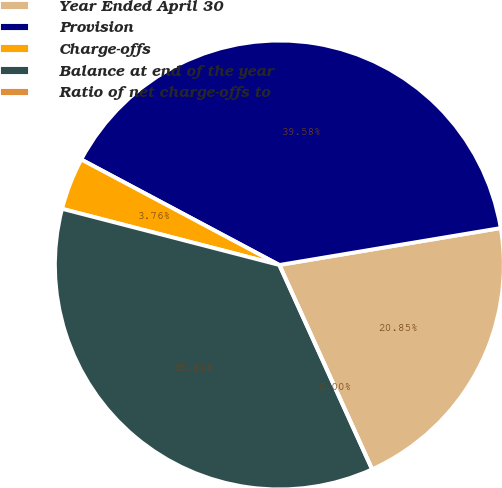<chart> <loc_0><loc_0><loc_500><loc_500><pie_chart><fcel>Year Ended April 30<fcel>Provision<fcel>Charge-offs<fcel>Balance at end of the year<fcel>Ratio of net charge-offs to<nl><fcel>20.85%<fcel>39.58%<fcel>3.76%<fcel>35.81%<fcel>0.0%<nl></chart> 